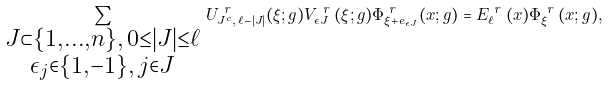<formula> <loc_0><loc_0><loc_500><loc_500>\sum _ { \substack { J \subset \{ 1 , \dots , n \} , \, 0 \leq | J | \leq \ell \\ \epsilon _ { j } \in \{ 1 , - 1 \} , \, j \in J } } \, U ^ { \emph { r } } _ { J ^ { c } , \, \ell - | J | } ( \xi ; g ) V ^ { \emph { r } } _ { \epsilon J } ( \xi ; g ) \Phi ^ { \emph { r } } _ { \xi + e _ { \epsilon J } } ( x ; g ) = E ^ { \emph { r } } _ { \ell } ( x ) \Phi ^ { \emph { r } } _ { \xi } ( x ; g ) ,</formula> 